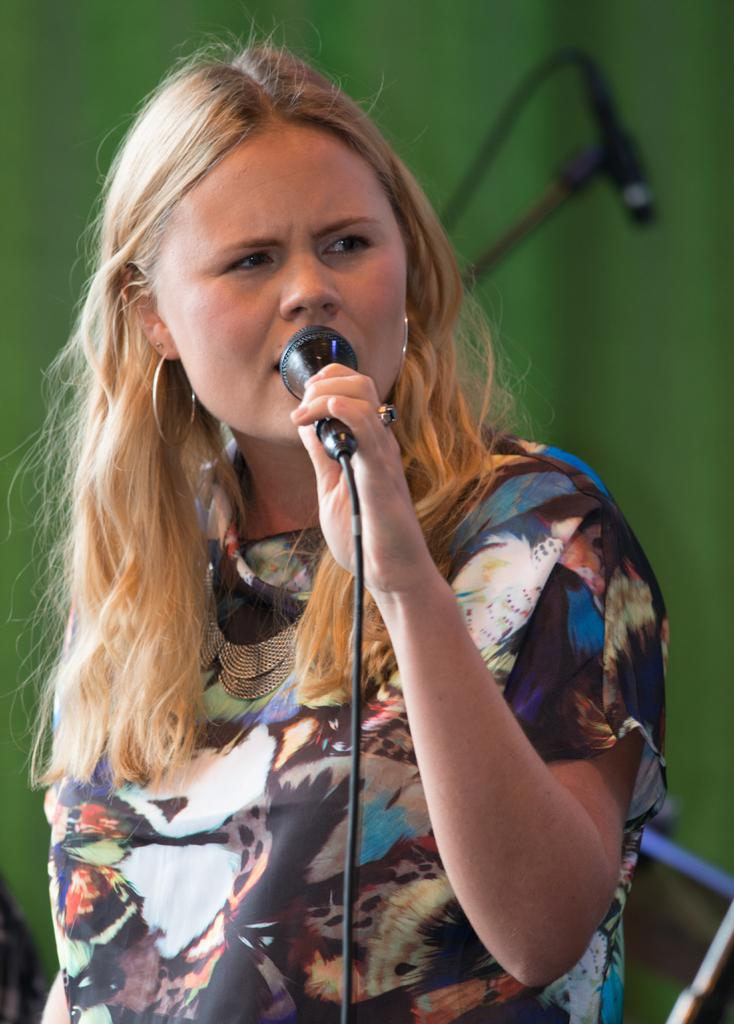Who is the main subject in the image? There is a woman in the image. What is the woman holding in her hand? The woman is holding a microphone in her hand. What is the woman doing with the microphone? The woman is talking. What can be seen in the background of the image? There is a microphone stand and a green-colored wall in the background of the image. How many oranges are on the woman's head in the image? There are no oranges present in the image, and the woman is not wearing a hat. 